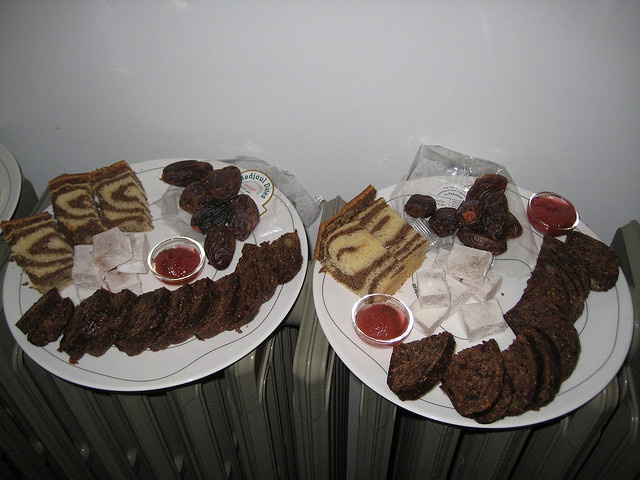Describe the objects in this image and their specific colors. I can see cake in gray, black, darkgray, and maroon tones, cake in gray, tan, and maroon tones, cake in gray, maroon, and black tones, cake in gray, black, and maroon tones, and cake in gray, black, and maroon tones in this image. 